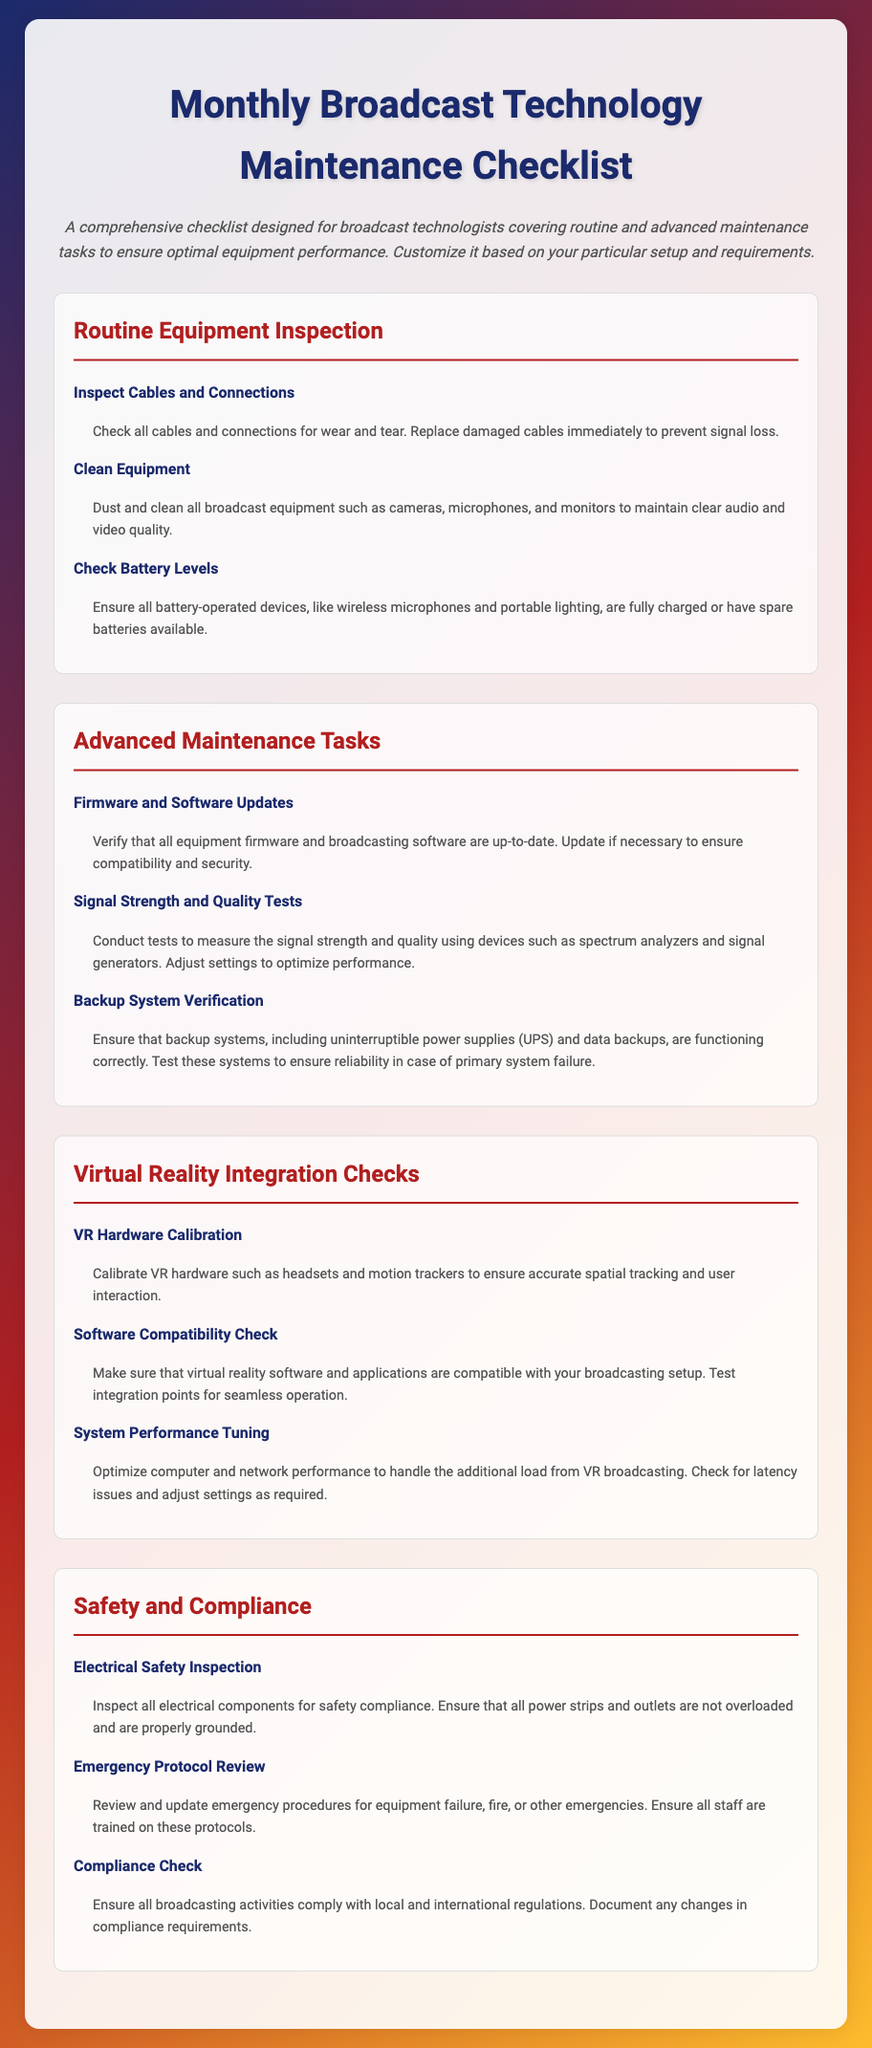what is the title of the document? The title is presented prominently at the top of the document, providing an overview of its contents.
Answer: Monthly Broadcast Technology Maintenance Checklist how many sections are in the document? The document contains several distinct sections, each dealing with different aspects of maintenance.
Answer: 4 what is the first task under Routine Equipment Inspection? The tasks are listed sequentially within the sections, with the first task being the most prominent.
Answer: Inspect Cables and Connections what is the purpose of the Backup System Verification task? The task is clearly described in the document and emphasizes the importance of backup systems to prevent data loss.
Answer: Ensure that backup systems are functioning correctly what should be checked during the Electrical Safety Inspection? The task description specifies what aspects should be inspected to ensure safety compliance.
Answer: Electrical components what is one of the tasks listed under Virtual Reality Integration Checks? The tasks are organized into categories, and one of them pertains specifically to VR technology.
Answer: VR Hardware Calibration how often should firmware and software updates be verified? While the document's language may not explicitly state the frequency, the context suggests a routine basis for maintenance tasks.
Answer: Monthly what does the Compliance Check ensure? The task focuses on ensuring adherence to certain regulations, which is critical in the broadcasting field.
Answer: Broadcasting activities comply with local and international regulations 